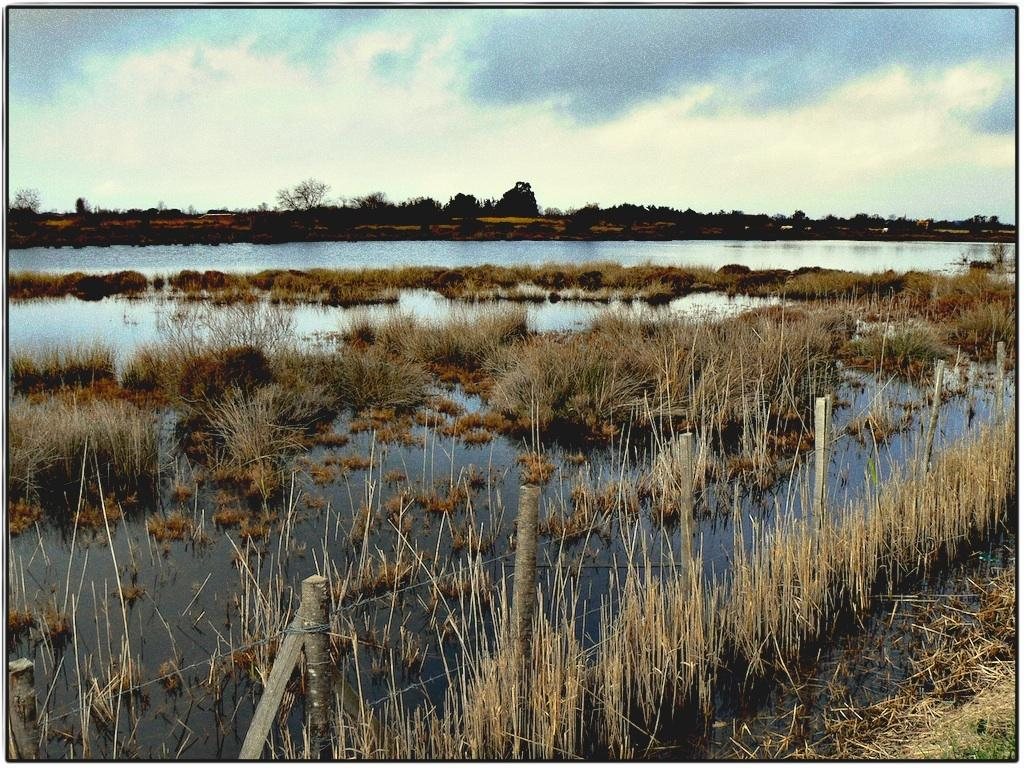What natural element can be seen in the image? Water is visible in the image. What type of barrier is present in the image? There is a fence in the image. What type of vegetation is present in the image? There is grass in the image. What is visible in the background of the image? The sky and trees are visible in the background of the image. What type of suit can be seen hanging on the fence in the image? There is no suit present in the image; it features water, a fence, grass, and trees in the background. Can you tell me how many plates are visible on the grass in the image? There are no plates present in the image. 